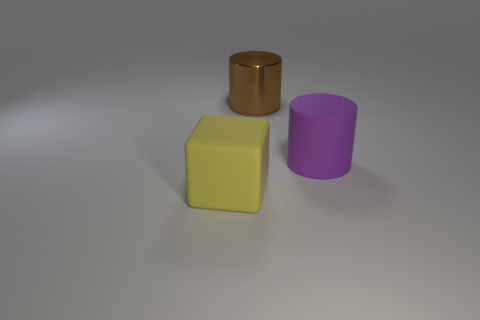How big is the matte object that is right of the object that is in front of the matte cylinder?
Give a very brief answer. Large. Do the large yellow object and the purple cylinder have the same material?
Make the answer very short. Yes. What number of large objects are either brown shiny things or cyan cylinders?
Give a very brief answer. 1. Is there any other thing that is the same shape as the yellow rubber object?
Ensure brevity in your answer.  No. What is the color of the thing that is made of the same material as the large block?
Give a very brief answer. Purple. What color is the rubber object that is left of the matte cylinder?
Your answer should be very brief. Yellow. Is the number of blocks to the left of the purple cylinder less than the number of big objects right of the yellow rubber cube?
Give a very brief answer. Yes. There is a brown thing; how many cubes are right of it?
Make the answer very short. 0. Is there a green cylinder made of the same material as the large purple cylinder?
Offer a terse response. No. Are there more big purple objects that are in front of the brown cylinder than brown metallic cylinders to the left of the big yellow thing?
Your answer should be very brief. Yes. 